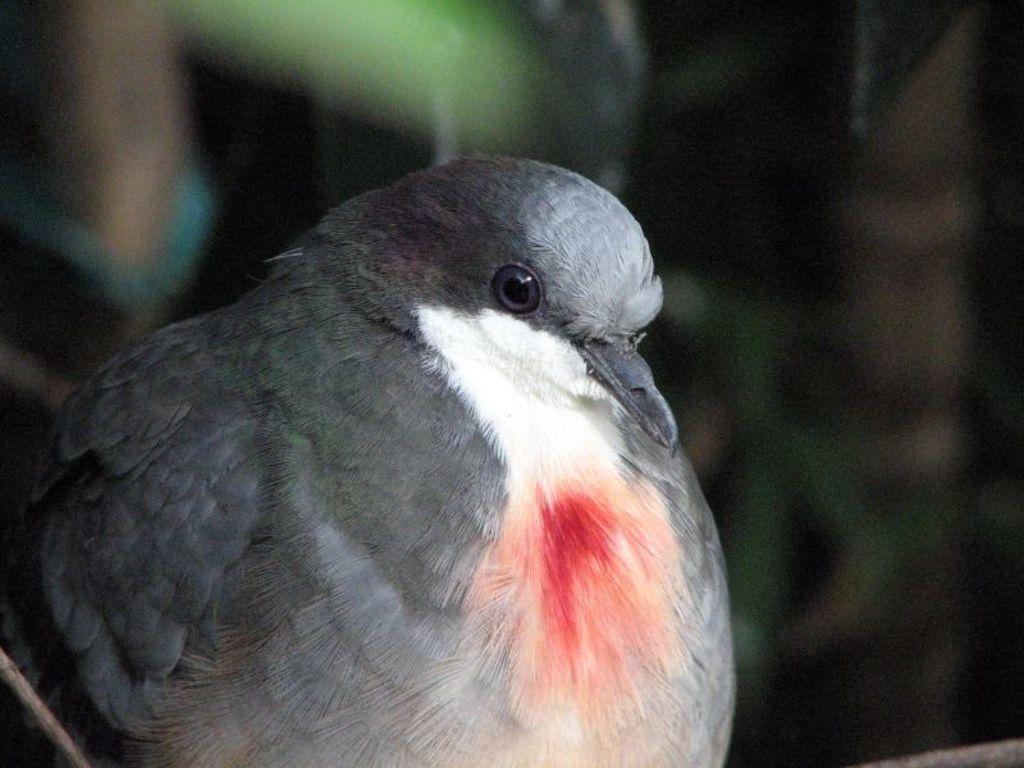Describe this image in one or two sentences. This is a zoomed in picture. In the foreground we can see a bird seems to be sitting. The background of the image is blurry. 